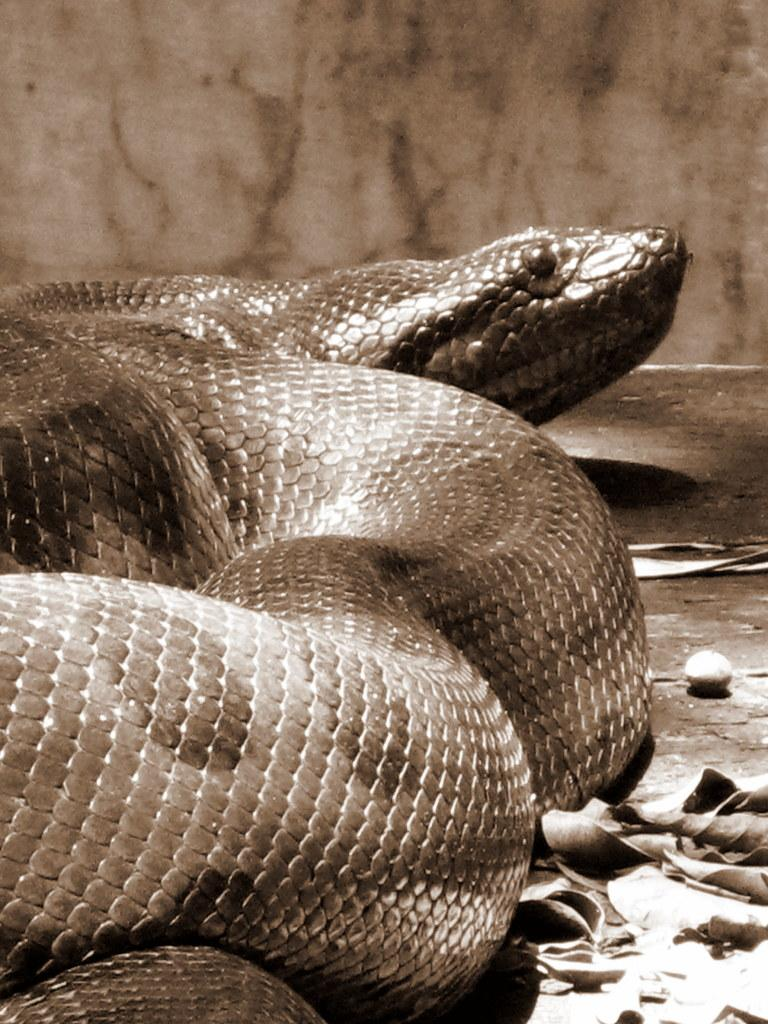What animal can be seen on the ground in the image? There is a snake on the ground in the image. What type of vegetation is present on the left side of the image? There are leaves on the left side of the image. What type of whip is being used to clean the snake in the image? There is no whip present in the image, nor is the snake being cleaned. 